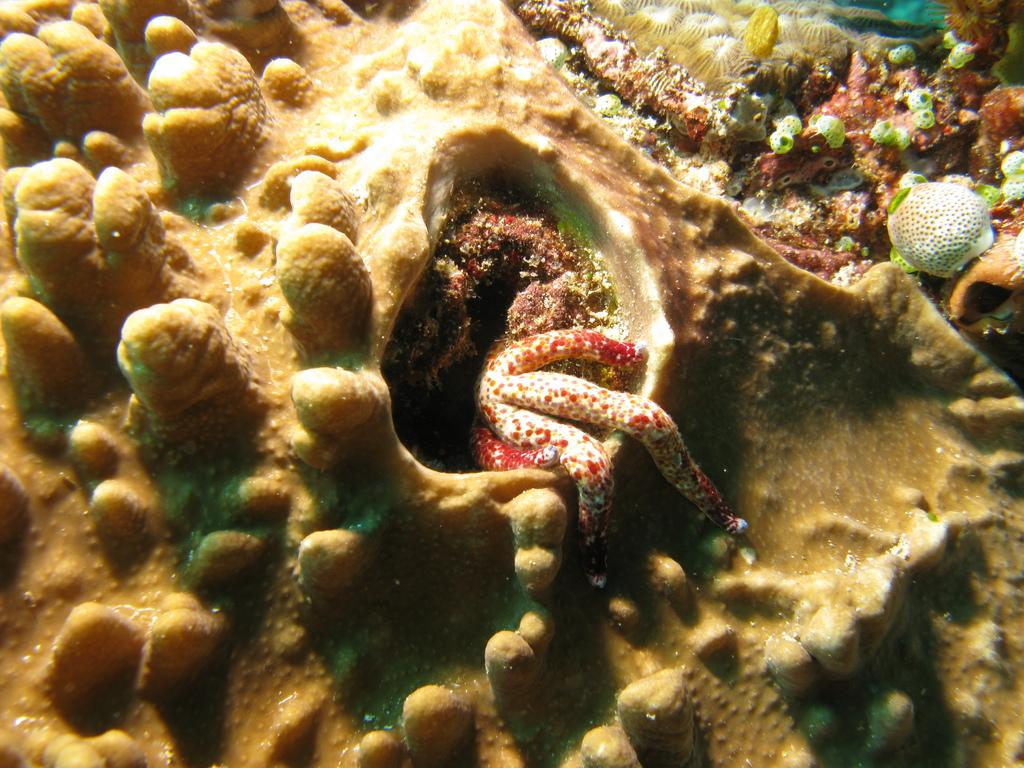What type of animal can be seen in the image? There is a water animal in the image. What can be found in the water alongside the animal? There are corals in the image. What type of tooth is visible in the image? There is no tooth visible in the image; it features a water animal and corals. Can you tell me how much profit the bird in the image is making? There is no bird present in the image, and therefore no profit can be associated with it. 